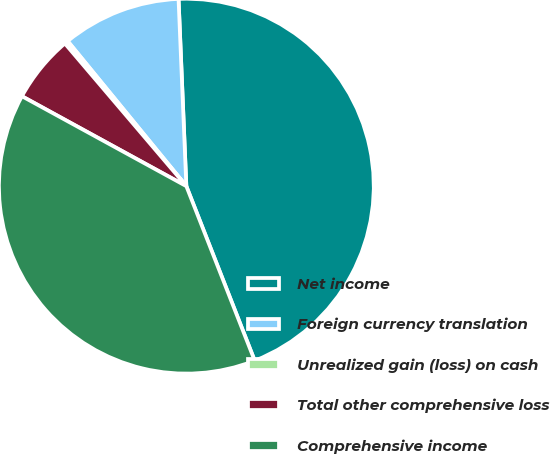<chart> <loc_0><loc_0><loc_500><loc_500><pie_chart><fcel>Net income<fcel>Foreign currency translation<fcel>Unrealized gain (loss) on cash<fcel>Total other comprehensive loss<fcel>Comprehensive income<nl><fcel>44.72%<fcel>10.25%<fcel>0.31%<fcel>5.81%<fcel>38.91%<nl></chart> 